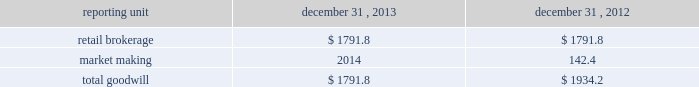Individual loan before being modified as a tdr in the discounted cash flow analysis in order to determine that specific loan 2019s expected impairment .
Specifically , a loan that has a more severe delinquency history prior to modification will have a higher future default rate in the discounted cash flow analysis than a loan that was not as severely delinquent .
For both of the one- to four-family and home equity loan portfolio segments , the pre- modification delinquency status , the borrower 2019s current credit score and other credit bureau attributes , in addition to each loan 2019s individual default experience and credit characteristics , are incorporated into the calculation of the specific allowance .
A specific allowance is established to the extent that the recorded investment exceeds the discounted cash flows of a tdr with a corresponding charge to provision for loan losses .
The specific allowance for these individually impaired loans represents the forecasted losses over the estimated remaining life of the loan , including the economic concession to the borrower .
Effects if actual results differ historic volatility in the credit markets has substantially increased the complexity and uncertainty involved in estimating the losses inherent in the loan portfolio .
In the current market it is difficult to estimate how potential changes in the quantitative and qualitative factors , including the impact of home equity lines of credit converting from interest only to amortizing loans or requiring borrowers to repay the loan in full at the end of the draw period , might impact the allowance for loan losses .
If our underlying assumptions and judgments prove to be inaccurate , the allowance for loan losses could be insufficient to cover actual losses .
We may be required under such circumstances to further increase the provision for loan losses , which could have an adverse effect on the regulatory capital position and results of operations in future periods .
During the normal course of conducting examinations , our banking regulators , the occ and federal reserve , continue to review our business and practices .
This process is dynamic and ongoing and we cannot be certain that additional changes or actions will not result from their continuing review .
Valuation of goodwill and other intangible assets description goodwill and other intangible assets are evaluated for impairment on an annual basis as of november 30 and in interim periods when events or changes indicate the carrying value may not be recoverable , such as a significant deterioration in the operating environment or a decision to sell or dispose of a reporting unit .
Goodwill and other intangible assets net of amortization were $ 1.8 billion and $ 0.2 billion , respectively , at december 31 , 2013 .
Judgments goodwill is allocated to reporting units , which are components of the business that are one level below operating segments .
Reporting units are evaluated for impairment individually during the annual assessment .
Estimating the fair value of reporting units and the assets , liabilities and intangible assets of a reporting unit is a subjective process that involves the use of estimates and judgments , particularly related to cash flows , the appropriate discount rates and an applicable control premium .
Management judgment is required to assess whether the carrying value of the reporting unit can be supported by the fair value of the individual reporting unit .
There are various valuation methodologies , such as the market approach or discounted cash flow methods , that may be used to estimate the fair value of reporting units .
In applying these methodologies , we utilize a number of factors , including actual operating results , future business plans , economic projections , and market data .
The table shows the comparative data for the amount of goodwill allocated to our reporting units ( dollars in millions ) : .

As of december 31 , what was the ratio of the retail brokerage goodwill to the market making goodwill? 
Rationale: as of december 31 , there was $ 12.6 of retail brokerage goodwill compared to the market making goodwill
Computations: (1791.8 / 142.4)
Answer: 12.58287. 